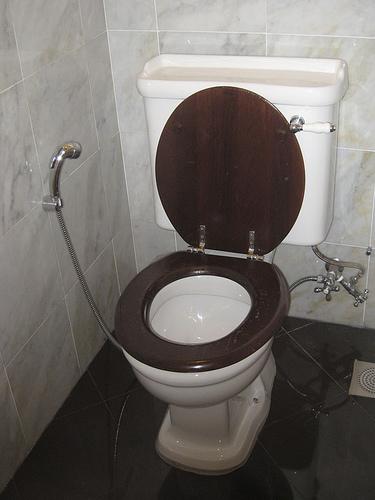What color are the floor tiles?
Keep it brief. Black. Will this toilet be replaced?
Keep it brief. No. Is the toilet seat up or down?
Keep it brief. Up. Does this room need repair?
Write a very short answer. No. To which direction is the plumbing located?
Write a very short answer. Right. 